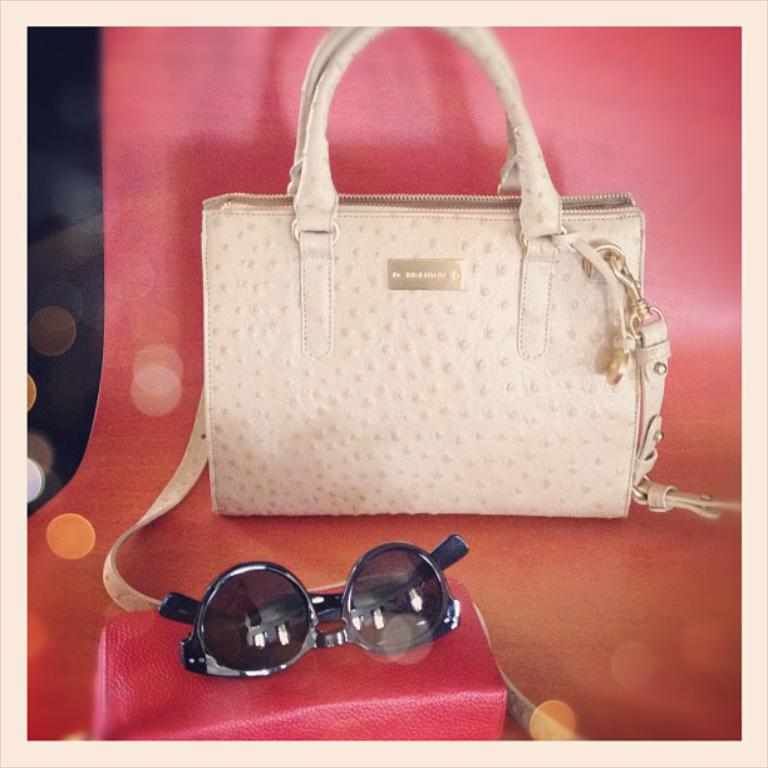What is placed on the sofa in the image? There is a handbag, spectacles, and a pouch on the sofa. Can you describe the objects on the sofa in more detail? The handbag is likely used for carrying personal items, the spectacles are for correcting vision, and the pouch might be used for storing smaller items. What type of ticket can be seen in the image? There is no ticket present in the image; the image only shows a handbag, spectacles, and a pouch on the sofa. 